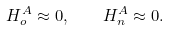Convert formula to latex. <formula><loc_0><loc_0><loc_500><loc_500>H _ { o } ^ { A } \approx 0 , \quad H _ { n } ^ { A } \approx 0 .</formula> 